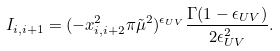<formula> <loc_0><loc_0><loc_500><loc_500>I _ { i , i + 1 } = ( - x _ { i , i + 2 } ^ { 2 } \pi \tilde { \mu } ^ { 2 } ) ^ { \epsilon _ { U V } } \frac { \Gamma ( 1 - \epsilon _ { U V } ) } { 2 \epsilon _ { U V } ^ { 2 } } .</formula> 